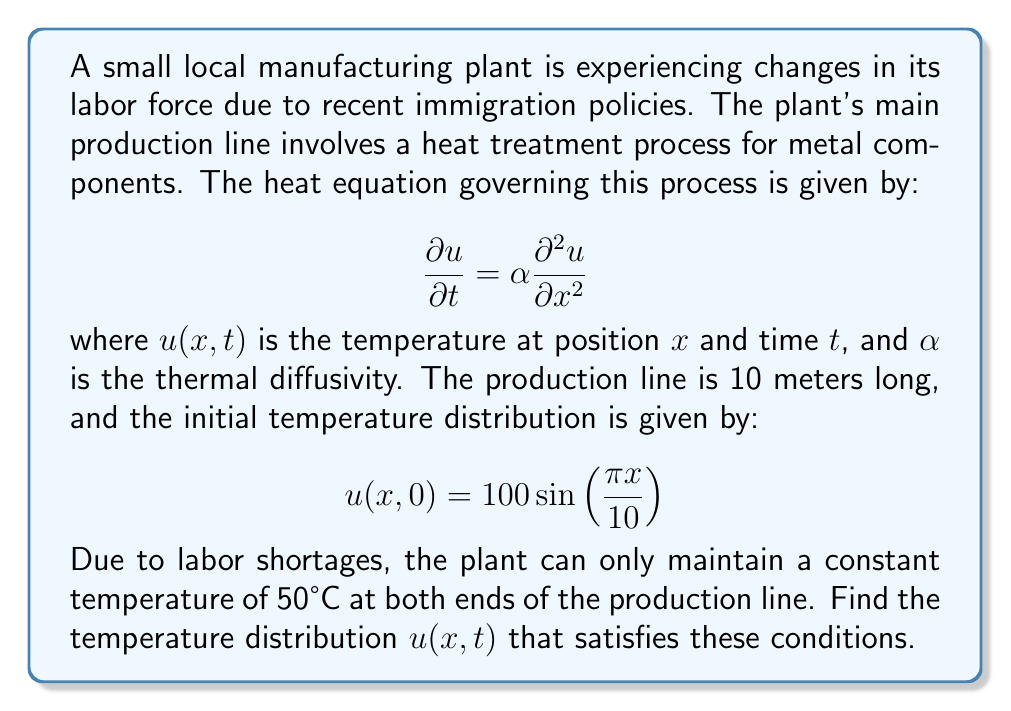Can you solve this math problem? To solve this heat equation problem, we'll follow these steps:

1) The heat equation is given by:
   $$\frac{\partial u}{\partial t} = \alpha \frac{\partial^2 u}{\partial x^2}$$

2) The boundary conditions are:
   $u(0,t) = u(10,t) = 50$ for all $t \geq 0$

3) The initial condition is:
   $u(x,0) = 100 \sin(\frac{\pi x}{10})$

4) To solve this, we'll use separation of variables. Let $u(x,t) = X(x)T(t)$

5) Substituting into the heat equation:
   $$X(x)T'(t) = \alpha X''(x)T(t)$$
   $$\frac{T'(t)}{T(t)} = \alpha \frac{X''(x)}{X(x)} = -\lambda$$

6) This gives us two ODEs:
   $T'(t) + \lambda \alpha T(t) = 0$
   $X''(x) + \lambda X(x) = 0$

7) The general solution for $X(x)$ is:
   $X(x) = A \cos(\sqrt{\lambda}x) + B \sin(\sqrt{\lambda}x)$

8) Applying the boundary conditions:
   $X(0) = A = 50$
   $X(10) = 50 \cos(10\sqrt{\lambda}) + B \sin(10\sqrt{\lambda}) = 50$

9) This gives us $\cos(10\sqrt{\lambda}) = 1$, so $\lambda_n = (\frac{n\pi}{10})^2$

10) The eigenfunction is:
    $X_n(x) = 50 + B_n \sin(\frac{n\pi x}{10})$

11) The general solution is:
    $$u(x,t) = 50 + \sum_{n=1}^{\infty} B_n \sin(\frac{n\pi x}{10}) e^{-\alpha (\frac{n\pi}{10})^2 t}$$

12) Using the initial condition to find $B_n$:
    $$100 \sin(\frac{\pi x}{10}) = \sum_{n=1}^{\infty} B_n \sin(\frac{n\pi x}{10})$$

13) This gives us $B_1 = 100$ and $B_n = 0$ for $n > 1$

Therefore, the final solution is:
$$u(x,t) = 50 + 100 \sin(\frac{\pi x}{10}) e^{-\alpha (\frac{\pi}{10})^2 t}$$
Answer: $u(x,t) = 50 + 100 \sin(\frac{\pi x}{10}) e^{-\alpha (\frac{\pi}{10})^2 t}$ 